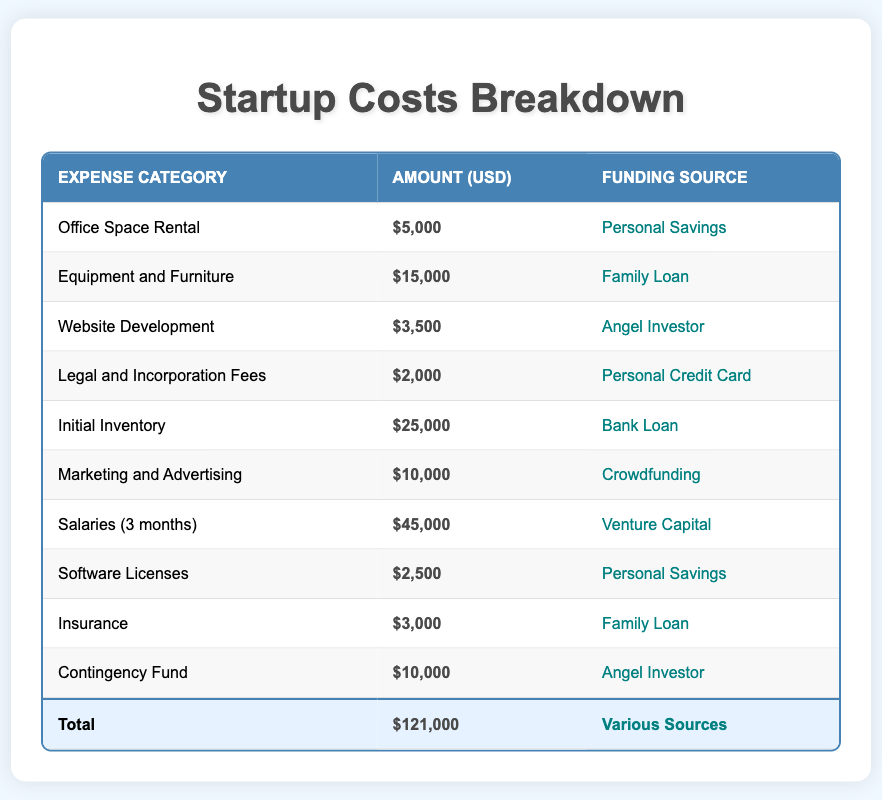What is the total amount of startup costs? The total amount is provided in the last row of the table under the 'Amount (USD)' column. It states $121,000, which is the sum of all the individual expenses listed above.
Answer: 121000 Which funding source was used for the largest single expense? Looking through the 'Amount (USD)' column, the largest single expense is for 'Salaries (3 months)', which costs $45,000. The funding source for this expense is 'Venture Capital', as indicated in the corresponding row.
Answer: Venture Capital Is there any expense funded by 'Crowdfunding'? The 'Marketing and Advertising' expense is the only one funded by 'Crowdfunding', showing a direct correlation between the expense and its funding source in the table.
Answer: Yes What is the combined total of expenses covered by personal savings? Two expenses are funded by 'Personal Savings': 'Office Space Rental' ($5,000) and 'Software Licenses' ($2,500). Adding these together gives a total of $7,500 ($5,000 + $2,500).
Answer: 7500 How much more is the initial inventory compared to the legal and incorporation fees? The 'Initial Inventory' cost is $25,000 while 'Legal and Incorporation Fees' is $2,000. To find out how much more expensive the initial inventory is, subtract the latter from the former: $25,000 - $2,000 = $23,000.
Answer: 23000 What percentage of the total costs does the 'Equipment and Furniture' expense represent? The 'Equipment and Furniture' expense is $15,000. To find the percentage of the total costs ($121,000), use the formula (15,000 / 121,000) * 100, which results in approximately 12.4%. Therefore, 'Equipment and Furniture' represents 12.4% of the total startup costs.
Answer: 12.4 Which category has the smallest amount listed and what is its funding source? The 'Legal and Incorporation Fees' is the smallest category with an amount of $2,000. The funding source for this expense is 'Personal Credit Card', as indicated in the table.
Answer: Personal Credit Card What is the average cost of the expenses funded by 'Family Loan'? Two expenses are funded by 'Family Loan': 'Equipment and Furniture' ($15,000) and 'Insurance' ($3,000). To calculate the average, first sum the two amounts: $15,000 + $3,000 = $18,000, then divide by the number of expenses (2): $18,000 / 2 = $9,000.
Answer: 9000 How many different funding sources are used in total? By counting the unique entries in the 'Funding Source' column, we see that there are 6 different sources: Personal Savings, Family Loan, Angel Investor, Personal Credit Card, Bank Loan, Crowdfunding, and Venture Capital. Altogether, they account for the various expenses listed.
Answer: 7 